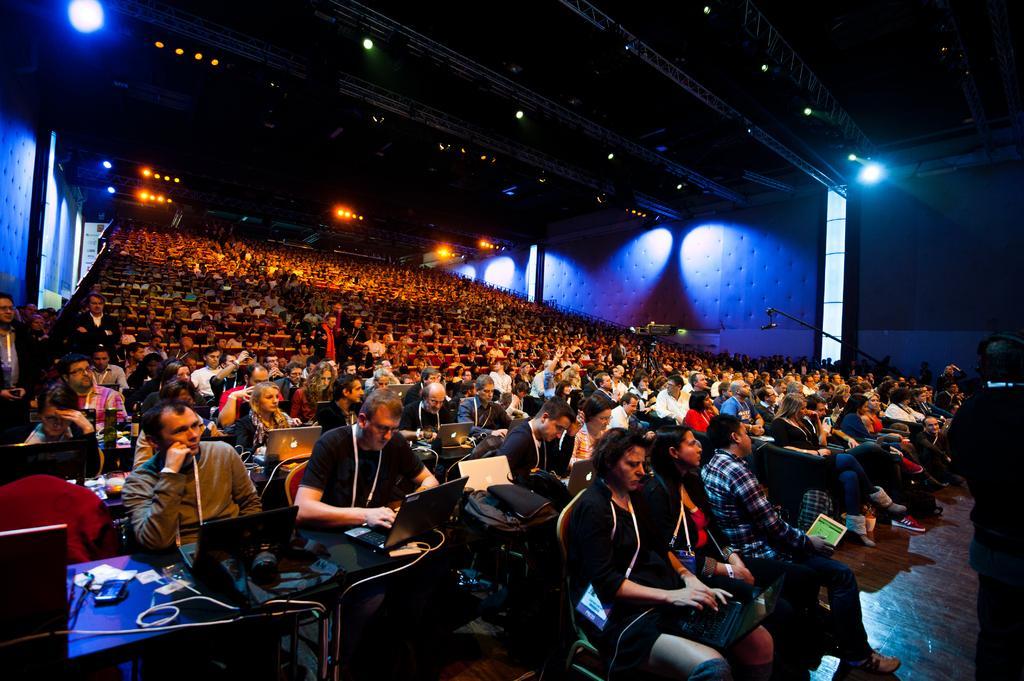Describe this image in one or two sentences. In this picture we can see so many people are sitting on the chairs in front there is a table on which we can see laptops, bags. 